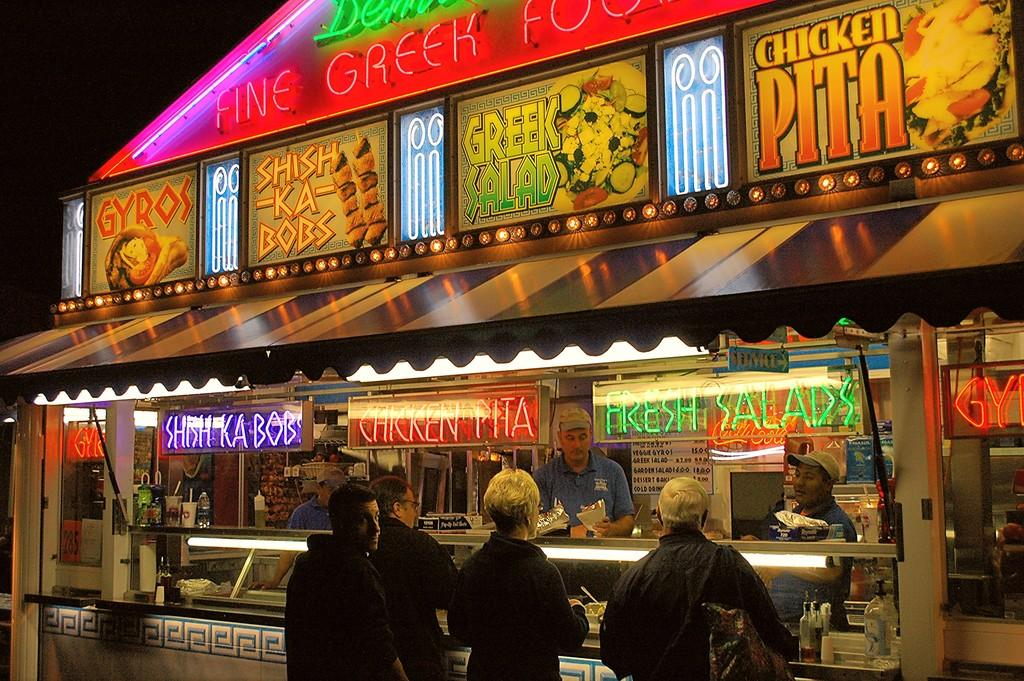How many people are in the image? There is a group of people in the image, but the exact number is not specified. What are the people doing in the image? The people are standing at a food stall in the image. What can be seen on the food stall? There are name boards and bottles visible on the food stall. What type of containers are present in the image? There are glasses in the image. What is providing shade in the image? There is a sun shade in the image. What is the color of the background in the image? The background of the image is dark. What type of game is being played by the people in the image? There is no game being played by the people in the image; they are standing at a food stall. How does the sense of smell play a role in the image? There is no information about the sense of smell in the image, as it focuses on the visual aspects of the scene. 